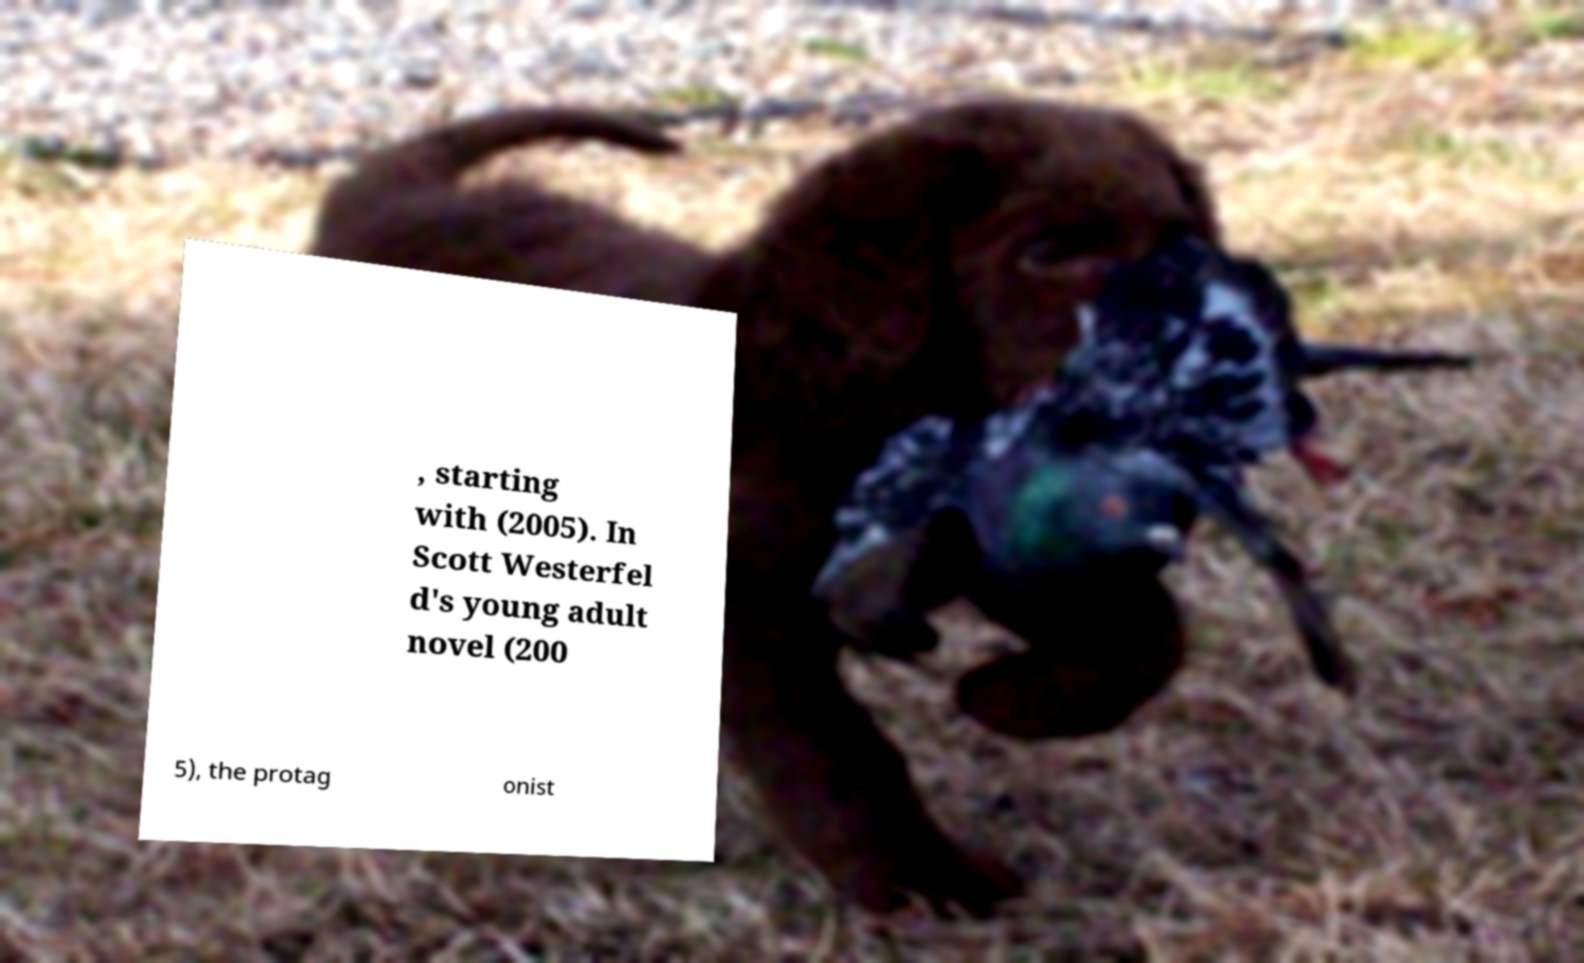Please identify and transcribe the text found in this image. , starting with (2005). In Scott Westerfel d's young adult novel (200 5), the protag onist 